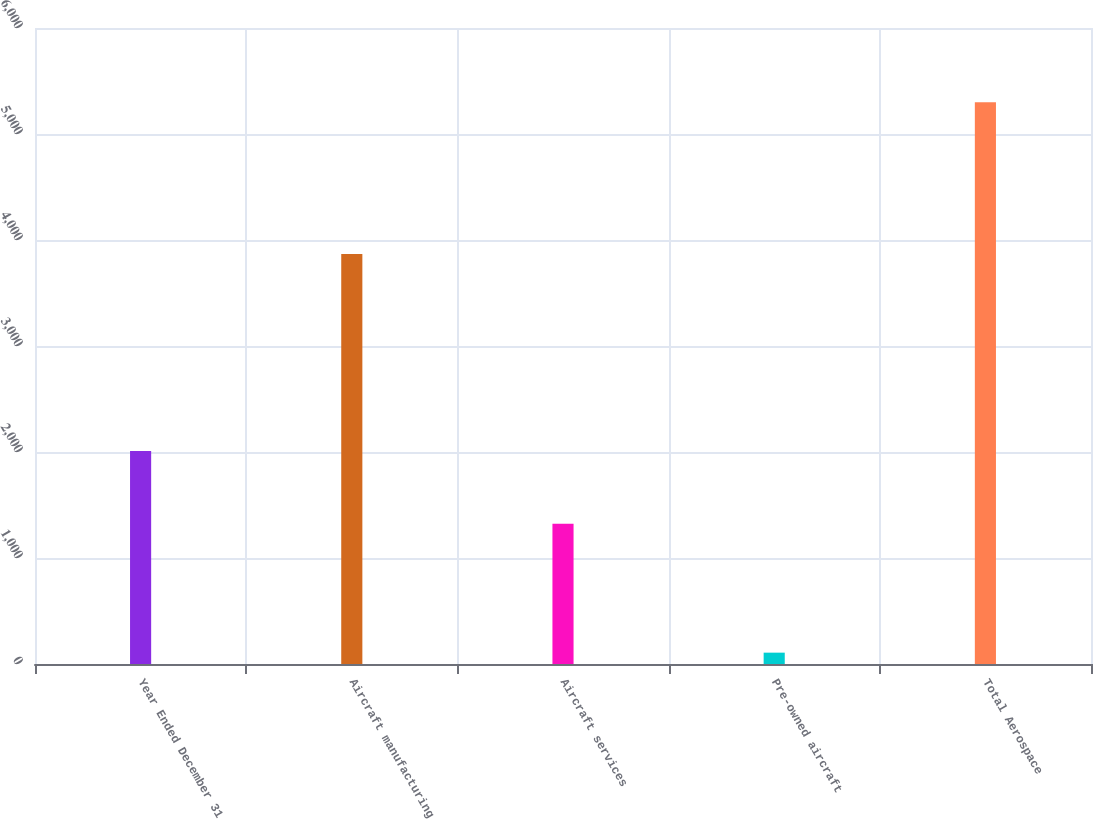Convert chart to OTSL. <chart><loc_0><loc_0><loc_500><loc_500><bar_chart><fcel>Year Ended December 31<fcel>Aircraft manufacturing<fcel>Aircraft services<fcel>Pre-owned aircraft<fcel>Total Aerospace<nl><fcel>2010<fcel>3869<fcel>1323<fcel>107<fcel>5299<nl></chart> 